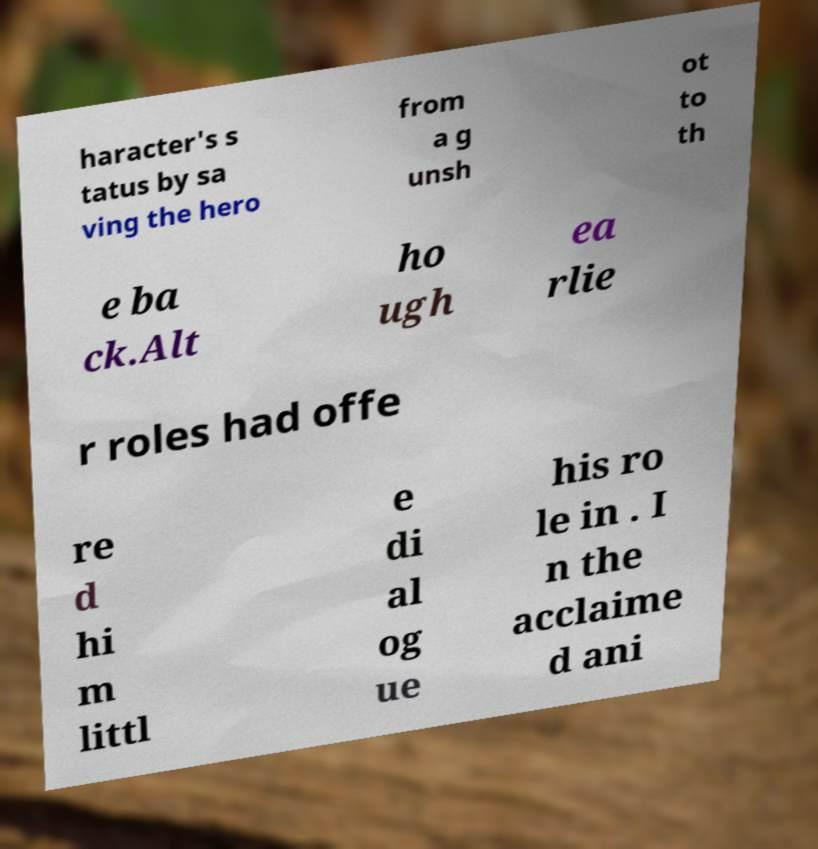Please read and relay the text visible in this image. What does it say? haracter's s tatus by sa ving the hero from a g unsh ot to th e ba ck.Alt ho ugh ea rlie r roles had offe re d hi m littl e di al og ue his ro le in . I n the acclaime d ani 